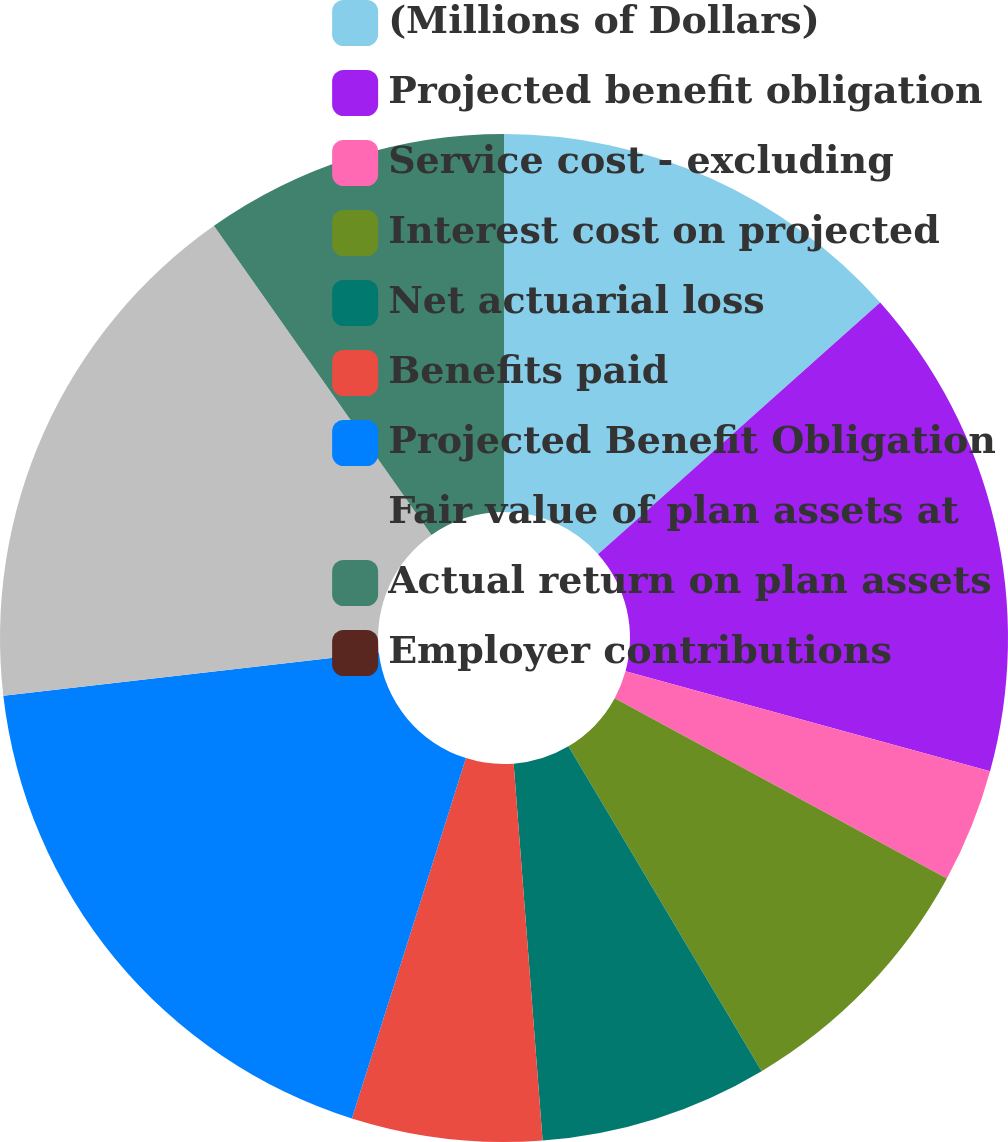<chart> <loc_0><loc_0><loc_500><loc_500><pie_chart><fcel>(Millions of Dollars)<fcel>Projected benefit obligation<fcel>Service cost - excluding<fcel>Interest cost on projected<fcel>Net actuarial loss<fcel>Benefits paid<fcel>Projected Benefit Obligation<fcel>Fair value of plan assets at<fcel>Actual return on plan assets<fcel>Employer contributions<nl><fcel>13.41%<fcel>15.85%<fcel>3.66%<fcel>8.54%<fcel>7.32%<fcel>6.1%<fcel>18.29%<fcel>17.07%<fcel>9.76%<fcel>0.0%<nl></chart> 